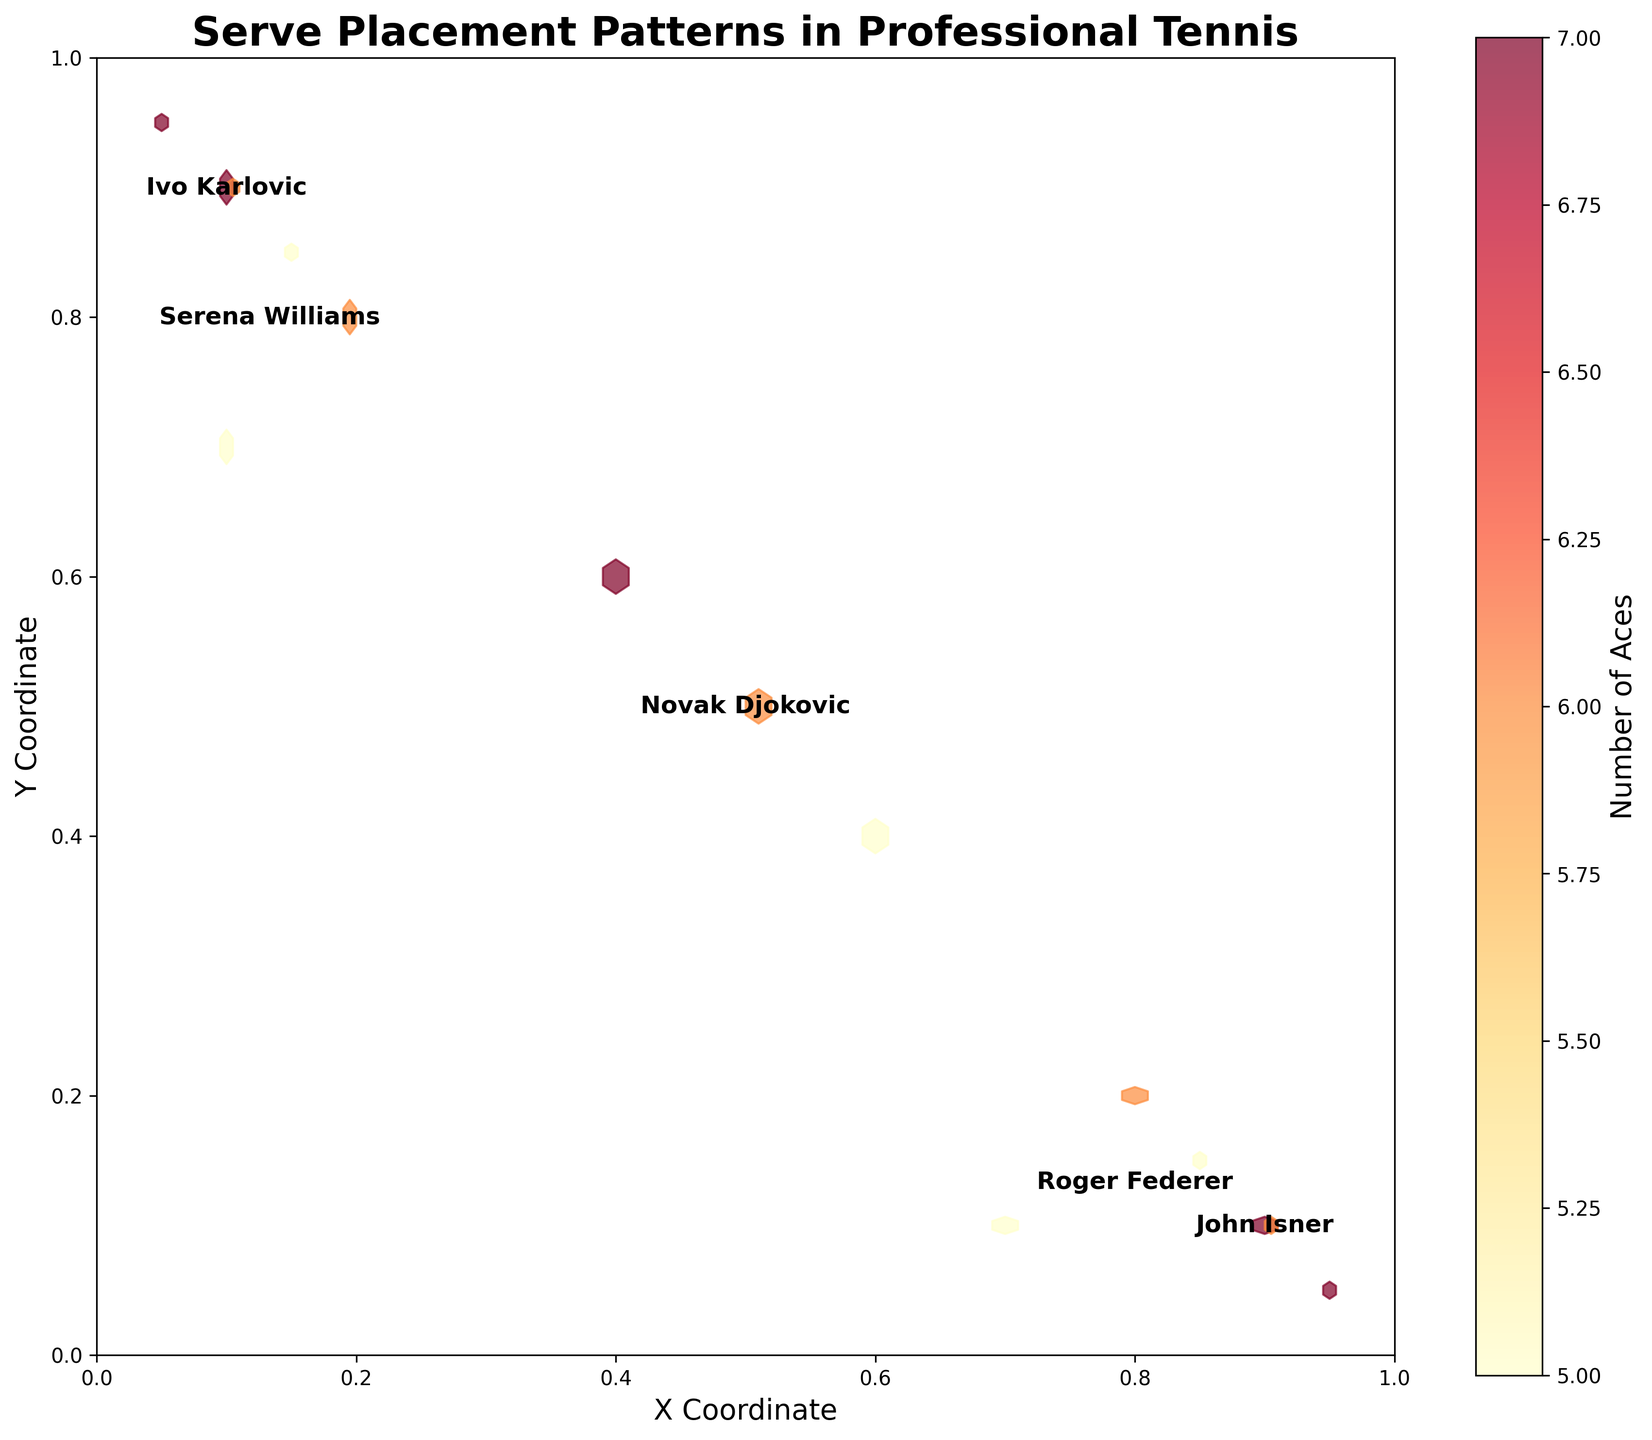Which player has the most aces in the plot? The color intensity on the hexbin plot corresponds to the number of aces. The most intense color on the plot is located in John Isner's area, indicating he has the most aces.
Answer: John Isner What is the title of the figure? The title is typically displayed at the top of the plot and describes the main subject of the figure. In this case, it reads: 'Serve Placement Patterns in Professional Tennis'.
Answer: Serve Placement Patterns in Professional Tennis How do the ace locations of Roger Federer compare to those of Serena Williams? By examining the hexbin clusters, we see Federer's serves are concentrated in the lower right area, while Williams' serves are located in the upper left. This signifies different serve strategies.
Answer: Different locations Which player has the serves placed closest to the center of the court? By finding the player with the data points closest to the center (0.5, 0.5), Novak Djokovic's points are the ones positioned nearer to the center compared to others.
Answer: Novak Djokovic Can we identify any player whose serves are predominantly to one side of the court? From the concentration of clusters, John Isner and Roger Federer mostly serve to the right side, with clusters positioned heavily on the right side of the plot.
Answer: John Isner and Roger Federer What's the coordinate range used for plotting the serves? The axes labels and ranges denote the plotted data. X and Y coordinates both range from 0 to 1, indicating the mapping from one side of the court to the other.
Answer: 0 to 1 Where are Serena Williams' aces predominantly located? Serena Williams' data points are clustered more heavily in the upper left quadrant of the plot, indicating she serves there more frequently.
Answer: Upper left How does Ivo Karlovic's serve pattern compare with John Isner's? Karlovic's serves are concentrated in the upper left area, while Isner's are in the lower right. This shows a distinct difference in their placement patterns.
Answer: Different areas What does the color bar represent in this hexbin plot? The provided color bar in the plot illustrates the number of aces, where varying colors signify the intensity or frequency of serves.
Answer: Number of Aces 